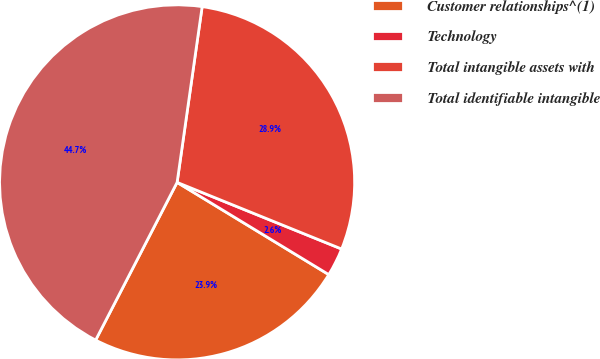Convert chart to OTSL. <chart><loc_0><loc_0><loc_500><loc_500><pie_chart><fcel>Customer relationships^(1)<fcel>Technology<fcel>Total intangible assets with<fcel>Total identifiable intangible<nl><fcel>23.89%<fcel>2.57%<fcel>28.87%<fcel>44.66%<nl></chart> 